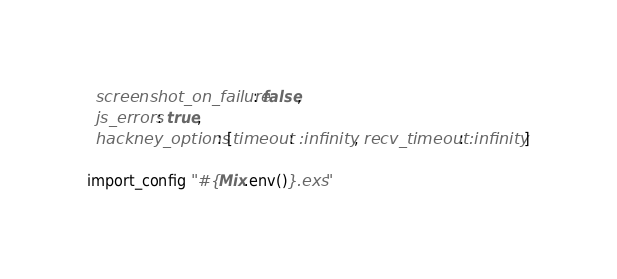<code> <loc_0><loc_0><loc_500><loc_500><_Elixir_>  screenshot_on_failure: false,
  js_errors: true,
  hackney_options: [timeout: :infinity, recv_timeout: :infinity]

import_config "#{Mix.env()}.exs"
</code> 